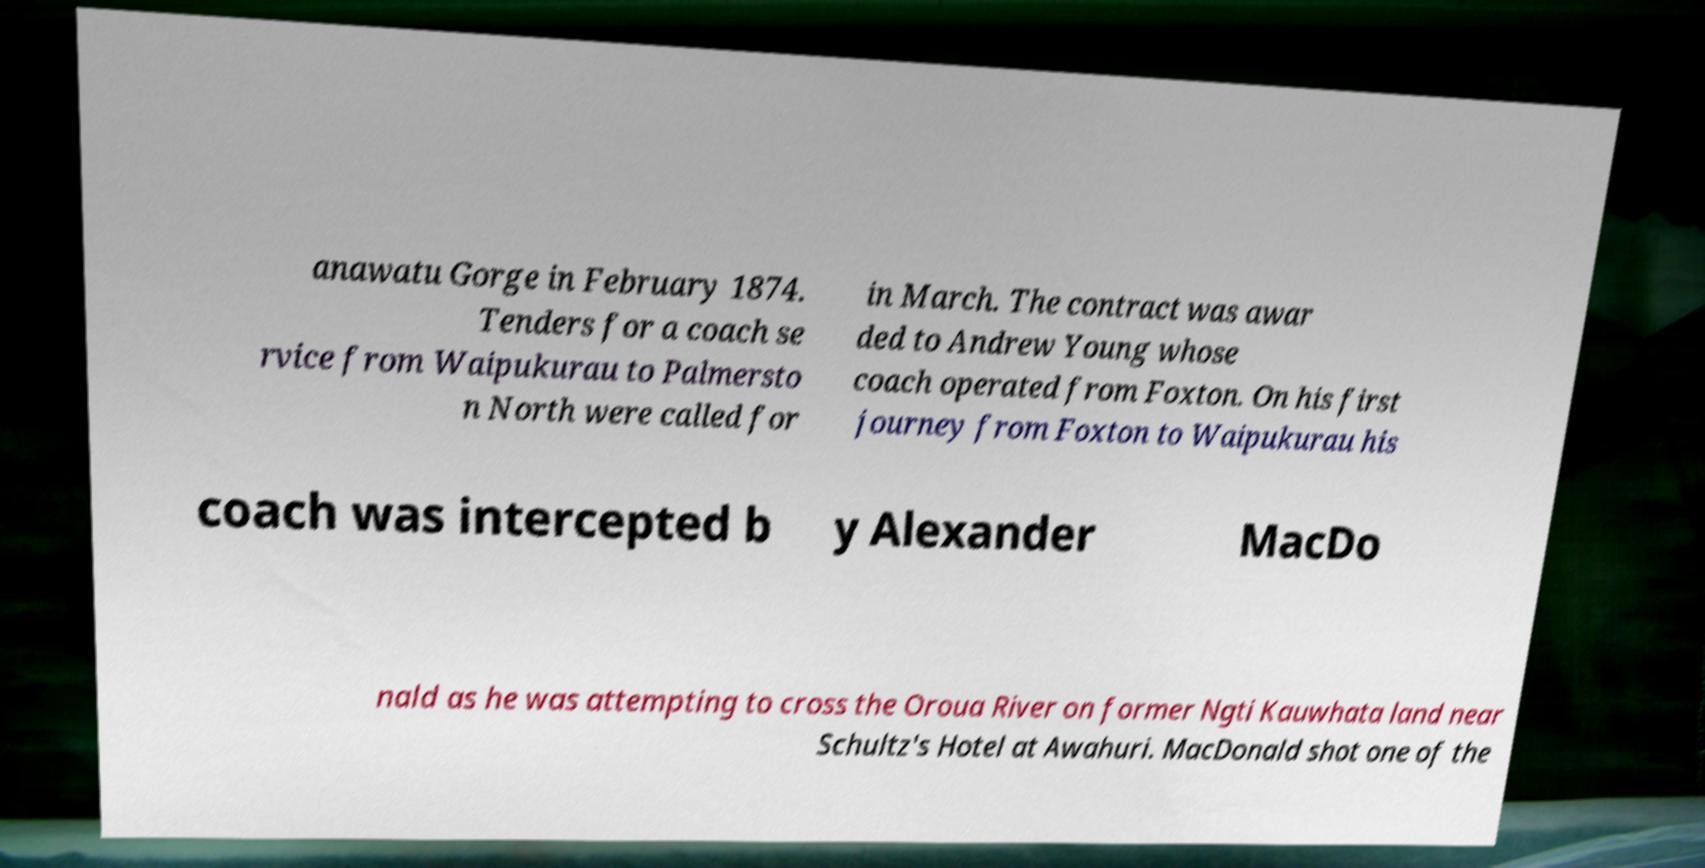What messages or text are displayed in this image? I need them in a readable, typed format. anawatu Gorge in February 1874. Tenders for a coach se rvice from Waipukurau to Palmersto n North were called for in March. The contract was awar ded to Andrew Young whose coach operated from Foxton. On his first journey from Foxton to Waipukurau his coach was intercepted b y Alexander MacDo nald as he was attempting to cross the Oroua River on former Ngti Kauwhata land near Schultz's Hotel at Awahuri. MacDonald shot one of the 